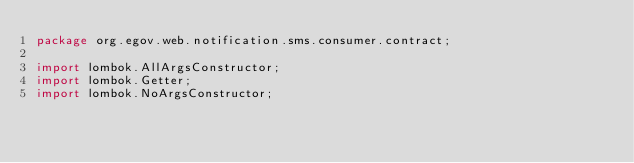Convert code to text. <code><loc_0><loc_0><loc_500><loc_500><_Java_>package org.egov.web.notification.sms.consumer.contract;

import lombok.AllArgsConstructor;
import lombok.Getter;
import lombok.NoArgsConstructor;
</code> 